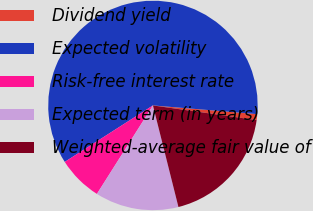<chart> <loc_0><loc_0><loc_500><loc_500><pie_chart><fcel>Dividend yield<fcel>Expected volatility<fcel>Risk-free interest rate<fcel>Expected term (in years)<fcel>Weighted-average fair value of<nl><fcel>0.91%<fcel>60.38%<fcel>6.95%<fcel>12.9%<fcel>18.85%<nl></chart> 